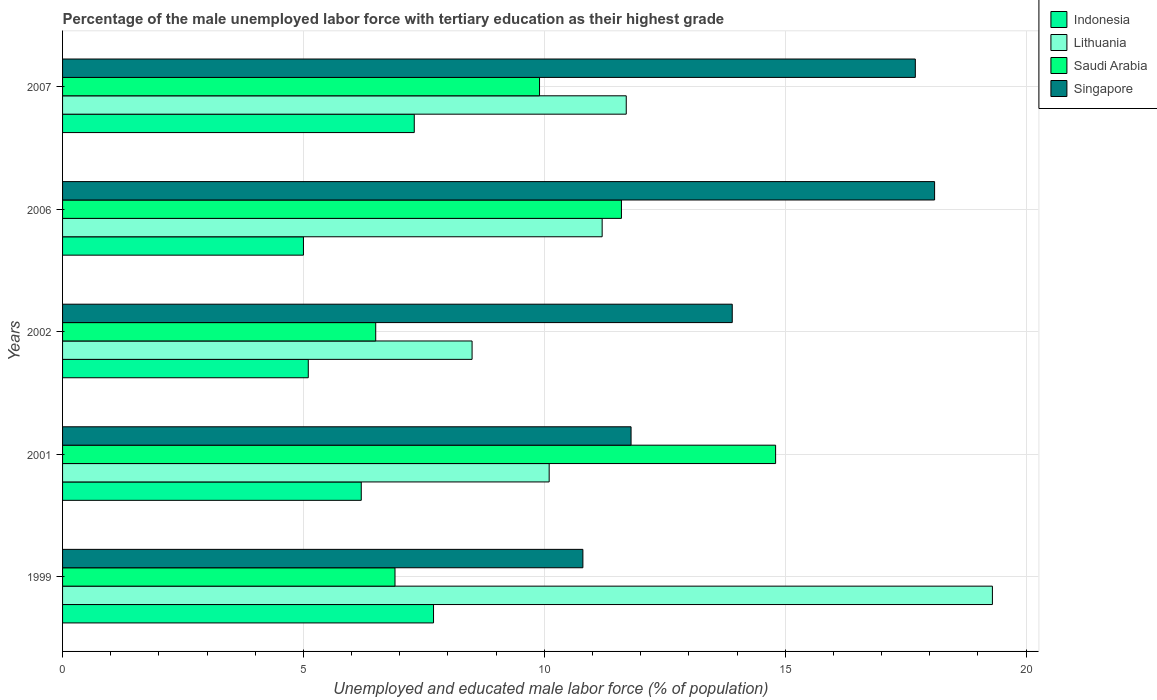How many groups of bars are there?
Offer a very short reply. 5. Are the number of bars per tick equal to the number of legend labels?
Ensure brevity in your answer.  Yes. How many bars are there on the 2nd tick from the top?
Provide a succinct answer. 4. What is the label of the 1st group of bars from the top?
Your answer should be compact. 2007. In how many cases, is the number of bars for a given year not equal to the number of legend labels?
Provide a short and direct response. 0. What is the percentage of the unemployed male labor force with tertiary education in Singapore in 2007?
Ensure brevity in your answer.  17.7. Across all years, what is the maximum percentage of the unemployed male labor force with tertiary education in Lithuania?
Give a very brief answer. 19.3. Across all years, what is the minimum percentage of the unemployed male labor force with tertiary education in Saudi Arabia?
Offer a terse response. 6.5. What is the total percentage of the unemployed male labor force with tertiary education in Singapore in the graph?
Make the answer very short. 72.3. What is the difference between the percentage of the unemployed male labor force with tertiary education in Singapore in 1999 and that in 2006?
Your answer should be very brief. -7.3. What is the difference between the percentage of the unemployed male labor force with tertiary education in Lithuania in 2006 and the percentage of the unemployed male labor force with tertiary education in Singapore in 2002?
Give a very brief answer. -2.7. What is the average percentage of the unemployed male labor force with tertiary education in Saudi Arabia per year?
Keep it short and to the point. 9.94. What is the ratio of the percentage of the unemployed male labor force with tertiary education in Singapore in 1999 to that in 2006?
Your answer should be very brief. 0.6. Is the percentage of the unemployed male labor force with tertiary education in Saudi Arabia in 2002 less than that in 2006?
Your response must be concise. Yes. What is the difference between the highest and the second highest percentage of the unemployed male labor force with tertiary education in Indonesia?
Your answer should be compact. 0.4. What is the difference between the highest and the lowest percentage of the unemployed male labor force with tertiary education in Singapore?
Your answer should be very brief. 7.3. In how many years, is the percentage of the unemployed male labor force with tertiary education in Singapore greater than the average percentage of the unemployed male labor force with tertiary education in Singapore taken over all years?
Offer a very short reply. 2. What does the 2nd bar from the top in 2002 represents?
Keep it short and to the point. Saudi Arabia. What does the 1st bar from the bottom in 2002 represents?
Offer a terse response. Indonesia. Is it the case that in every year, the sum of the percentage of the unemployed male labor force with tertiary education in Saudi Arabia and percentage of the unemployed male labor force with tertiary education in Singapore is greater than the percentage of the unemployed male labor force with tertiary education in Lithuania?
Ensure brevity in your answer.  No. Does the graph contain grids?
Provide a short and direct response. Yes. Where does the legend appear in the graph?
Offer a very short reply. Top right. How many legend labels are there?
Provide a short and direct response. 4. How are the legend labels stacked?
Keep it short and to the point. Vertical. What is the title of the graph?
Keep it short and to the point. Percentage of the male unemployed labor force with tertiary education as their highest grade. Does "Ethiopia" appear as one of the legend labels in the graph?
Make the answer very short. No. What is the label or title of the X-axis?
Make the answer very short. Unemployed and educated male labor force (% of population). What is the label or title of the Y-axis?
Provide a short and direct response. Years. What is the Unemployed and educated male labor force (% of population) in Indonesia in 1999?
Your answer should be compact. 7.7. What is the Unemployed and educated male labor force (% of population) of Lithuania in 1999?
Your response must be concise. 19.3. What is the Unemployed and educated male labor force (% of population) in Saudi Arabia in 1999?
Ensure brevity in your answer.  6.9. What is the Unemployed and educated male labor force (% of population) of Singapore in 1999?
Keep it short and to the point. 10.8. What is the Unemployed and educated male labor force (% of population) in Indonesia in 2001?
Your response must be concise. 6.2. What is the Unemployed and educated male labor force (% of population) in Lithuania in 2001?
Offer a very short reply. 10.1. What is the Unemployed and educated male labor force (% of population) in Saudi Arabia in 2001?
Keep it short and to the point. 14.8. What is the Unemployed and educated male labor force (% of population) of Singapore in 2001?
Give a very brief answer. 11.8. What is the Unemployed and educated male labor force (% of population) in Indonesia in 2002?
Your answer should be compact. 5.1. What is the Unemployed and educated male labor force (% of population) of Lithuania in 2002?
Provide a succinct answer. 8.5. What is the Unemployed and educated male labor force (% of population) in Singapore in 2002?
Your response must be concise. 13.9. What is the Unemployed and educated male labor force (% of population) in Lithuania in 2006?
Your answer should be very brief. 11.2. What is the Unemployed and educated male labor force (% of population) in Saudi Arabia in 2006?
Your answer should be very brief. 11.6. What is the Unemployed and educated male labor force (% of population) of Singapore in 2006?
Your answer should be very brief. 18.1. What is the Unemployed and educated male labor force (% of population) in Indonesia in 2007?
Your answer should be compact. 7.3. What is the Unemployed and educated male labor force (% of population) in Lithuania in 2007?
Provide a short and direct response. 11.7. What is the Unemployed and educated male labor force (% of population) in Saudi Arabia in 2007?
Your response must be concise. 9.9. What is the Unemployed and educated male labor force (% of population) in Singapore in 2007?
Ensure brevity in your answer.  17.7. Across all years, what is the maximum Unemployed and educated male labor force (% of population) in Indonesia?
Keep it short and to the point. 7.7. Across all years, what is the maximum Unemployed and educated male labor force (% of population) in Lithuania?
Offer a terse response. 19.3. Across all years, what is the maximum Unemployed and educated male labor force (% of population) of Saudi Arabia?
Ensure brevity in your answer.  14.8. Across all years, what is the maximum Unemployed and educated male labor force (% of population) in Singapore?
Make the answer very short. 18.1. Across all years, what is the minimum Unemployed and educated male labor force (% of population) of Indonesia?
Your answer should be very brief. 5. Across all years, what is the minimum Unemployed and educated male labor force (% of population) in Lithuania?
Ensure brevity in your answer.  8.5. Across all years, what is the minimum Unemployed and educated male labor force (% of population) in Singapore?
Your answer should be compact. 10.8. What is the total Unemployed and educated male labor force (% of population) in Indonesia in the graph?
Provide a succinct answer. 31.3. What is the total Unemployed and educated male labor force (% of population) in Lithuania in the graph?
Your response must be concise. 60.8. What is the total Unemployed and educated male labor force (% of population) of Saudi Arabia in the graph?
Give a very brief answer. 49.7. What is the total Unemployed and educated male labor force (% of population) in Singapore in the graph?
Offer a very short reply. 72.3. What is the difference between the Unemployed and educated male labor force (% of population) of Indonesia in 1999 and that in 2001?
Offer a terse response. 1.5. What is the difference between the Unemployed and educated male labor force (% of population) of Lithuania in 1999 and that in 2001?
Give a very brief answer. 9.2. What is the difference between the Unemployed and educated male labor force (% of population) of Saudi Arabia in 1999 and that in 2001?
Your answer should be very brief. -7.9. What is the difference between the Unemployed and educated male labor force (% of population) in Lithuania in 1999 and that in 2002?
Offer a terse response. 10.8. What is the difference between the Unemployed and educated male labor force (% of population) of Indonesia in 1999 and that in 2006?
Your answer should be very brief. 2.7. What is the difference between the Unemployed and educated male labor force (% of population) in Saudi Arabia in 1999 and that in 2006?
Provide a short and direct response. -4.7. What is the difference between the Unemployed and educated male labor force (% of population) of Singapore in 1999 and that in 2006?
Provide a short and direct response. -7.3. What is the difference between the Unemployed and educated male labor force (% of population) in Indonesia in 1999 and that in 2007?
Provide a short and direct response. 0.4. What is the difference between the Unemployed and educated male labor force (% of population) in Lithuania in 1999 and that in 2007?
Offer a terse response. 7.6. What is the difference between the Unemployed and educated male labor force (% of population) of Singapore in 1999 and that in 2007?
Offer a terse response. -6.9. What is the difference between the Unemployed and educated male labor force (% of population) of Indonesia in 2001 and that in 2002?
Your answer should be very brief. 1.1. What is the difference between the Unemployed and educated male labor force (% of population) of Saudi Arabia in 2001 and that in 2007?
Make the answer very short. 4.9. What is the difference between the Unemployed and educated male labor force (% of population) in Indonesia in 2002 and that in 2006?
Ensure brevity in your answer.  0.1. What is the difference between the Unemployed and educated male labor force (% of population) of Lithuania in 2002 and that in 2006?
Keep it short and to the point. -2.7. What is the difference between the Unemployed and educated male labor force (% of population) of Saudi Arabia in 2002 and that in 2006?
Offer a very short reply. -5.1. What is the difference between the Unemployed and educated male labor force (% of population) in Singapore in 2002 and that in 2006?
Give a very brief answer. -4.2. What is the difference between the Unemployed and educated male labor force (% of population) in Saudi Arabia in 2002 and that in 2007?
Give a very brief answer. -3.4. What is the difference between the Unemployed and educated male labor force (% of population) of Singapore in 2002 and that in 2007?
Make the answer very short. -3.8. What is the difference between the Unemployed and educated male labor force (% of population) in Indonesia in 2006 and that in 2007?
Offer a terse response. -2.3. What is the difference between the Unemployed and educated male labor force (% of population) in Lithuania in 2006 and that in 2007?
Make the answer very short. -0.5. What is the difference between the Unemployed and educated male labor force (% of population) of Saudi Arabia in 2006 and that in 2007?
Keep it short and to the point. 1.7. What is the difference between the Unemployed and educated male labor force (% of population) in Singapore in 2006 and that in 2007?
Keep it short and to the point. 0.4. What is the difference between the Unemployed and educated male labor force (% of population) in Indonesia in 1999 and the Unemployed and educated male labor force (% of population) in Lithuania in 2001?
Your answer should be compact. -2.4. What is the difference between the Unemployed and educated male labor force (% of population) of Indonesia in 1999 and the Unemployed and educated male labor force (% of population) of Saudi Arabia in 2001?
Keep it short and to the point. -7.1. What is the difference between the Unemployed and educated male labor force (% of population) of Indonesia in 1999 and the Unemployed and educated male labor force (% of population) of Lithuania in 2002?
Your answer should be very brief. -0.8. What is the difference between the Unemployed and educated male labor force (% of population) of Indonesia in 1999 and the Unemployed and educated male labor force (% of population) of Singapore in 2002?
Provide a short and direct response. -6.2. What is the difference between the Unemployed and educated male labor force (% of population) in Lithuania in 1999 and the Unemployed and educated male labor force (% of population) in Saudi Arabia in 2002?
Provide a short and direct response. 12.8. What is the difference between the Unemployed and educated male labor force (% of population) in Lithuania in 1999 and the Unemployed and educated male labor force (% of population) in Singapore in 2002?
Your answer should be compact. 5.4. What is the difference between the Unemployed and educated male labor force (% of population) of Indonesia in 1999 and the Unemployed and educated male labor force (% of population) of Lithuania in 2006?
Keep it short and to the point. -3.5. What is the difference between the Unemployed and educated male labor force (% of population) in Indonesia in 1999 and the Unemployed and educated male labor force (% of population) in Saudi Arabia in 2006?
Offer a very short reply. -3.9. What is the difference between the Unemployed and educated male labor force (% of population) in Indonesia in 1999 and the Unemployed and educated male labor force (% of population) in Singapore in 2006?
Offer a very short reply. -10.4. What is the difference between the Unemployed and educated male labor force (% of population) of Lithuania in 1999 and the Unemployed and educated male labor force (% of population) of Saudi Arabia in 2006?
Your answer should be very brief. 7.7. What is the difference between the Unemployed and educated male labor force (% of population) of Lithuania in 1999 and the Unemployed and educated male labor force (% of population) of Singapore in 2006?
Give a very brief answer. 1.2. What is the difference between the Unemployed and educated male labor force (% of population) in Saudi Arabia in 1999 and the Unemployed and educated male labor force (% of population) in Singapore in 2006?
Ensure brevity in your answer.  -11.2. What is the difference between the Unemployed and educated male labor force (% of population) in Indonesia in 1999 and the Unemployed and educated male labor force (% of population) in Lithuania in 2007?
Give a very brief answer. -4. What is the difference between the Unemployed and educated male labor force (% of population) of Indonesia in 1999 and the Unemployed and educated male labor force (% of population) of Saudi Arabia in 2007?
Provide a succinct answer. -2.2. What is the difference between the Unemployed and educated male labor force (% of population) of Indonesia in 1999 and the Unemployed and educated male labor force (% of population) of Singapore in 2007?
Offer a very short reply. -10. What is the difference between the Unemployed and educated male labor force (% of population) in Lithuania in 1999 and the Unemployed and educated male labor force (% of population) in Saudi Arabia in 2007?
Offer a very short reply. 9.4. What is the difference between the Unemployed and educated male labor force (% of population) in Lithuania in 1999 and the Unemployed and educated male labor force (% of population) in Singapore in 2007?
Your answer should be compact. 1.6. What is the difference between the Unemployed and educated male labor force (% of population) in Indonesia in 2001 and the Unemployed and educated male labor force (% of population) in Lithuania in 2002?
Ensure brevity in your answer.  -2.3. What is the difference between the Unemployed and educated male labor force (% of population) in Indonesia in 2001 and the Unemployed and educated male labor force (% of population) in Saudi Arabia in 2002?
Make the answer very short. -0.3. What is the difference between the Unemployed and educated male labor force (% of population) of Indonesia in 2001 and the Unemployed and educated male labor force (% of population) of Singapore in 2002?
Give a very brief answer. -7.7. What is the difference between the Unemployed and educated male labor force (% of population) in Saudi Arabia in 2001 and the Unemployed and educated male labor force (% of population) in Singapore in 2002?
Offer a terse response. 0.9. What is the difference between the Unemployed and educated male labor force (% of population) of Indonesia in 2001 and the Unemployed and educated male labor force (% of population) of Lithuania in 2006?
Make the answer very short. -5. What is the difference between the Unemployed and educated male labor force (% of population) of Indonesia in 2001 and the Unemployed and educated male labor force (% of population) of Saudi Arabia in 2006?
Keep it short and to the point. -5.4. What is the difference between the Unemployed and educated male labor force (% of population) in Indonesia in 2001 and the Unemployed and educated male labor force (% of population) in Singapore in 2006?
Offer a very short reply. -11.9. What is the difference between the Unemployed and educated male labor force (% of population) in Saudi Arabia in 2001 and the Unemployed and educated male labor force (% of population) in Singapore in 2006?
Keep it short and to the point. -3.3. What is the difference between the Unemployed and educated male labor force (% of population) in Lithuania in 2001 and the Unemployed and educated male labor force (% of population) in Saudi Arabia in 2007?
Provide a succinct answer. 0.2. What is the difference between the Unemployed and educated male labor force (% of population) in Indonesia in 2002 and the Unemployed and educated male labor force (% of population) in Singapore in 2006?
Offer a terse response. -13. What is the difference between the Unemployed and educated male labor force (% of population) in Lithuania in 2002 and the Unemployed and educated male labor force (% of population) in Saudi Arabia in 2006?
Your answer should be compact. -3.1. What is the difference between the Unemployed and educated male labor force (% of population) of Saudi Arabia in 2002 and the Unemployed and educated male labor force (% of population) of Singapore in 2006?
Ensure brevity in your answer.  -11.6. What is the difference between the Unemployed and educated male labor force (% of population) in Indonesia in 2002 and the Unemployed and educated male labor force (% of population) in Saudi Arabia in 2007?
Offer a terse response. -4.8. What is the difference between the Unemployed and educated male labor force (% of population) of Indonesia in 2002 and the Unemployed and educated male labor force (% of population) of Singapore in 2007?
Ensure brevity in your answer.  -12.6. What is the difference between the Unemployed and educated male labor force (% of population) of Indonesia in 2006 and the Unemployed and educated male labor force (% of population) of Saudi Arabia in 2007?
Give a very brief answer. -4.9. What is the average Unemployed and educated male labor force (% of population) in Indonesia per year?
Provide a succinct answer. 6.26. What is the average Unemployed and educated male labor force (% of population) of Lithuania per year?
Ensure brevity in your answer.  12.16. What is the average Unemployed and educated male labor force (% of population) of Saudi Arabia per year?
Make the answer very short. 9.94. What is the average Unemployed and educated male labor force (% of population) of Singapore per year?
Offer a terse response. 14.46. In the year 1999, what is the difference between the Unemployed and educated male labor force (% of population) in Indonesia and Unemployed and educated male labor force (% of population) in Lithuania?
Offer a very short reply. -11.6. In the year 1999, what is the difference between the Unemployed and educated male labor force (% of population) in Indonesia and Unemployed and educated male labor force (% of population) in Singapore?
Offer a terse response. -3.1. In the year 1999, what is the difference between the Unemployed and educated male labor force (% of population) of Lithuania and Unemployed and educated male labor force (% of population) of Singapore?
Provide a short and direct response. 8.5. In the year 1999, what is the difference between the Unemployed and educated male labor force (% of population) of Saudi Arabia and Unemployed and educated male labor force (% of population) of Singapore?
Provide a short and direct response. -3.9. In the year 2001, what is the difference between the Unemployed and educated male labor force (% of population) in Indonesia and Unemployed and educated male labor force (% of population) in Lithuania?
Make the answer very short. -3.9. In the year 2001, what is the difference between the Unemployed and educated male labor force (% of population) of Indonesia and Unemployed and educated male labor force (% of population) of Singapore?
Provide a succinct answer. -5.6. In the year 2001, what is the difference between the Unemployed and educated male labor force (% of population) of Lithuania and Unemployed and educated male labor force (% of population) of Saudi Arabia?
Make the answer very short. -4.7. In the year 2001, what is the difference between the Unemployed and educated male labor force (% of population) of Saudi Arabia and Unemployed and educated male labor force (% of population) of Singapore?
Your response must be concise. 3. In the year 2002, what is the difference between the Unemployed and educated male labor force (% of population) of Lithuania and Unemployed and educated male labor force (% of population) of Saudi Arabia?
Your answer should be very brief. 2. In the year 2002, what is the difference between the Unemployed and educated male labor force (% of population) of Saudi Arabia and Unemployed and educated male labor force (% of population) of Singapore?
Offer a terse response. -7.4. In the year 2006, what is the difference between the Unemployed and educated male labor force (% of population) of Indonesia and Unemployed and educated male labor force (% of population) of Lithuania?
Your answer should be very brief. -6.2. In the year 2006, what is the difference between the Unemployed and educated male labor force (% of population) in Indonesia and Unemployed and educated male labor force (% of population) in Saudi Arabia?
Your response must be concise. -6.6. In the year 2006, what is the difference between the Unemployed and educated male labor force (% of population) of Indonesia and Unemployed and educated male labor force (% of population) of Singapore?
Your response must be concise. -13.1. In the year 2007, what is the difference between the Unemployed and educated male labor force (% of population) of Indonesia and Unemployed and educated male labor force (% of population) of Lithuania?
Provide a succinct answer. -4.4. In the year 2007, what is the difference between the Unemployed and educated male labor force (% of population) of Indonesia and Unemployed and educated male labor force (% of population) of Saudi Arabia?
Provide a short and direct response. -2.6. In the year 2007, what is the difference between the Unemployed and educated male labor force (% of population) of Indonesia and Unemployed and educated male labor force (% of population) of Singapore?
Keep it short and to the point. -10.4. In the year 2007, what is the difference between the Unemployed and educated male labor force (% of population) of Lithuania and Unemployed and educated male labor force (% of population) of Saudi Arabia?
Give a very brief answer. 1.8. In the year 2007, what is the difference between the Unemployed and educated male labor force (% of population) of Lithuania and Unemployed and educated male labor force (% of population) of Singapore?
Provide a succinct answer. -6. In the year 2007, what is the difference between the Unemployed and educated male labor force (% of population) of Saudi Arabia and Unemployed and educated male labor force (% of population) of Singapore?
Offer a very short reply. -7.8. What is the ratio of the Unemployed and educated male labor force (% of population) in Indonesia in 1999 to that in 2001?
Give a very brief answer. 1.24. What is the ratio of the Unemployed and educated male labor force (% of population) of Lithuania in 1999 to that in 2001?
Your answer should be very brief. 1.91. What is the ratio of the Unemployed and educated male labor force (% of population) of Saudi Arabia in 1999 to that in 2001?
Your answer should be very brief. 0.47. What is the ratio of the Unemployed and educated male labor force (% of population) in Singapore in 1999 to that in 2001?
Offer a terse response. 0.92. What is the ratio of the Unemployed and educated male labor force (% of population) of Indonesia in 1999 to that in 2002?
Your answer should be compact. 1.51. What is the ratio of the Unemployed and educated male labor force (% of population) in Lithuania in 1999 to that in 2002?
Ensure brevity in your answer.  2.27. What is the ratio of the Unemployed and educated male labor force (% of population) of Saudi Arabia in 1999 to that in 2002?
Your answer should be compact. 1.06. What is the ratio of the Unemployed and educated male labor force (% of population) of Singapore in 1999 to that in 2002?
Provide a short and direct response. 0.78. What is the ratio of the Unemployed and educated male labor force (% of population) of Indonesia in 1999 to that in 2006?
Your response must be concise. 1.54. What is the ratio of the Unemployed and educated male labor force (% of population) of Lithuania in 1999 to that in 2006?
Your response must be concise. 1.72. What is the ratio of the Unemployed and educated male labor force (% of population) of Saudi Arabia in 1999 to that in 2006?
Your answer should be very brief. 0.59. What is the ratio of the Unemployed and educated male labor force (% of population) in Singapore in 1999 to that in 2006?
Your answer should be compact. 0.6. What is the ratio of the Unemployed and educated male labor force (% of population) in Indonesia in 1999 to that in 2007?
Offer a very short reply. 1.05. What is the ratio of the Unemployed and educated male labor force (% of population) of Lithuania in 1999 to that in 2007?
Your response must be concise. 1.65. What is the ratio of the Unemployed and educated male labor force (% of population) of Saudi Arabia in 1999 to that in 2007?
Offer a very short reply. 0.7. What is the ratio of the Unemployed and educated male labor force (% of population) in Singapore in 1999 to that in 2007?
Your answer should be compact. 0.61. What is the ratio of the Unemployed and educated male labor force (% of population) in Indonesia in 2001 to that in 2002?
Provide a succinct answer. 1.22. What is the ratio of the Unemployed and educated male labor force (% of population) in Lithuania in 2001 to that in 2002?
Your response must be concise. 1.19. What is the ratio of the Unemployed and educated male labor force (% of population) in Saudi Arabia in 2001 to that in 2002?
Your answer should be compact. 2.28. What is the ratio of the Unemployed and educated male labor force (% of population) in Singapore in 2001 to that in 2002?
Provide a succinct answer. 0.85. What is the ratio of the Unemployed and educated male labor force (% of population) in Indonesia in 2001 to that in 2006?
Offer a very short reply. 1.24. What is the ratio of the Unemployed and educated male labor force (% of population) in Lithuania in 2001 to that in 2006?
Provide a succinct answer. 0.9. What is the ratio of the Unemployed and educated male labor force (% of population) of Saudi Arabia in 2001 to that in 2006?
Offer a terse response. 1.28. What is the ratio of the Unemployed and educated male labor force (% of population) in Singapore in 2001 to that in 2006?
Your answer should be very brief. 0.65. What is the ratio of the Unemployed and educated male labor force (% of population) of Indonesia in 2001 to that in 2007?
Your answer should be very brief. 0.85. What is the ratio of the Unemployed and educated male labor force (% of population) of Lithuania in 2001 to that in 2007?
Your answer should be very brief. 0.86. What is the ratio of the Unemployed and educated male labor force (% of population) in Saudi Arabia in 2001 to that in 2007?
Keep it short and to the point. 1.49. What is the ratio of the Unemployed and educated male labor force (% of population) of Lithuania in 2002 to that in 2006?
Offer a terse response. 0.76. What is the ratio of the Unemployed and educated male labor force (% of population) in Saudi Arabia in 2002 to that in 2006?
Your answer should be compact. 0.56. What is the ratio of the Unemployed and educated male labor force (% of population) of Singapore in 2002 to that in 2006?
Ensure brevity in your answer.  0.77. What is the ratio of the Unemployed and educated male labor force (% of population) of Indonesia in 2002 to that in 2007?
Your answer should be very brief. 0.7. What is the ratio of the Unemployed and educated male labor force (% of population) of Lithuania in 2002 to that in 2007?
Provide a succinct answer. 0.73. What is the ratio of the Unemployed and educated male labor force (% of population) in Saudi Arabia in 2002 to that in 2007?
Your response must be concise. 0.66. What is the ratio of the Unemployed and educated male labor force (% of population) in Singapore in 2002 to that in 2007?
Make the answer very short. 0.79. What is the ratio of the Unemployed and educated male labor force (% of population) in Indonesia in 2006 to that in 2007?
Your answer should be compact. 0.68. What is the ratio of the Unemployed and educated male labor force (% of population) in Lithuania in 2006 to that in 2007?
Offer a terse response. 0.96. What is the ratio of the Unemployed and educated male labor force (% of population) in Saudi Arabia in 2006 to that in 2007?
Provide a short and direct response. 1.17. What is the ratio of the Unemployed and educated male labor force (% of population) of Singapore in 2006 to that in 2007?
Your response must be concise. 1.02. What is the difference between the highest and the second highest Unemployed and educated male labor force (% of population) of Saudi Arabia?
Offer a terse response. 3.2. What is the difference between the highest and the lowest Unemployed and educated male labor force (% of population) in Saudi Arabia?
Your response must be concise. 8.3. 